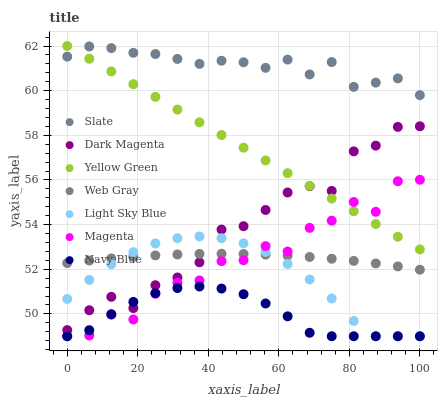Does Navy Blue have the minimum area under the curve?
Answer yes or no. Yes. Does Slate have the maximum area under the curve?
Answer yes or no. Yes. Does Dark Magenta have the minimum area under the curve?
Answer yes or no. No. Does Dark Magenta have the maximum area under the curve?
Answer yes or no. No. Is Yellow Green the smoothest?
Answer yes or no. Yes. Is Magenta the roughest?
Answer yes or no. Yes. Is Dark Magenta the smoothest?
Answer yes or no. No. Is Dark Magenta the roughest?
Answer yes or no. No. Does Navy Blue have the lowest value?
Answer yes or no. Yes. Does Dark Magenta have the lowest value?
Answer yes or no. No. Does Yellow Green have the highest value?
Answer yes or no. Yes. Does Dark Magenta have the highest value?
Answer yes or no. No. Is Magenta less than Dark Magenta?
Answer yes or no. Yes. Is Slate greater than Light Sky Blue?
Answer yes or no. Yes. Does Navy Blue intersect Magenta?
Answer yes or no. Yes. Is Navy Blue less than Magenta?
Answer yes or no. No. Is Navy Blue greater than Magenta?
Answer yes or no. No. Does Magenta intersect Dark Magenta?
Answer yes or no. No. 